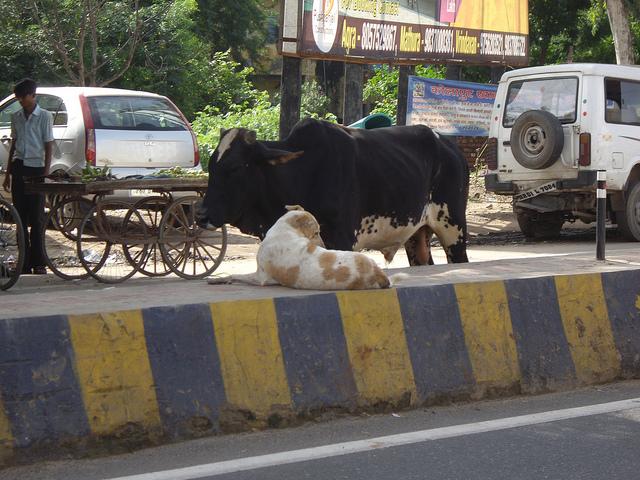What animal is sitting in front of the cow?
Keep it brief. Dog. How many wheels are on the cart on the left?
Quick response, please. 4. Are the two animals fighting?
Keep it brief. No. 